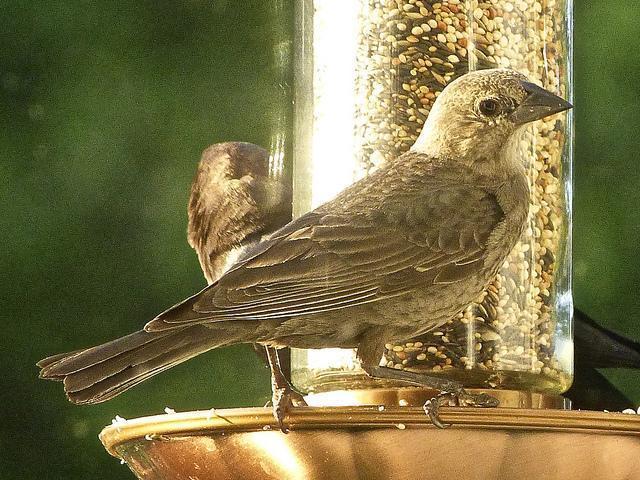How many birds?
Give a very brief answer. 2. How many birds are visible?
Give a very brief answer. 2. How many women are on a bicycle?
Give a very brief answer. 0. 